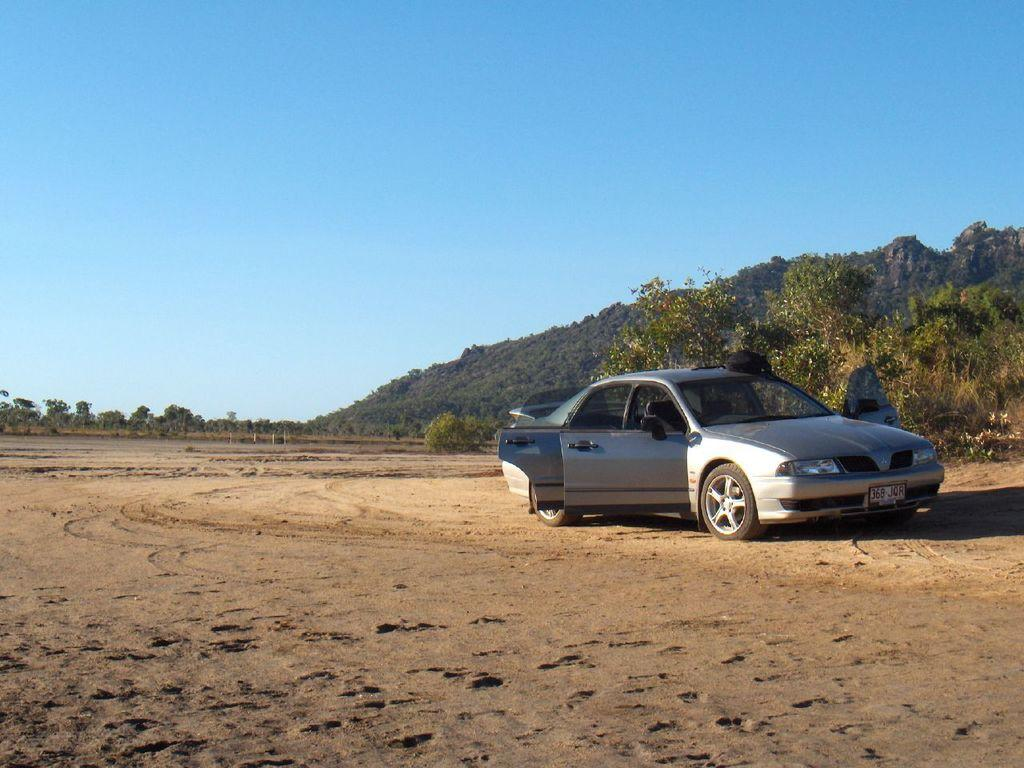What is the black object on the car in the image? The fact does not specify the nature of the black object on the car, so we cannot determine its purpose or identity from the given information. What type of terrain is visible in the image? Sand is visible in the image, suggesting a desert or beach environment. What can be seen in the background of the image? There are plants and trees in the background of the image. What is the color of the sky in the image? The sky is blue in color. What type of grape is being used to create steam in the image? There is no grape or steam present in the image, so this question cannot be answered definitively. 